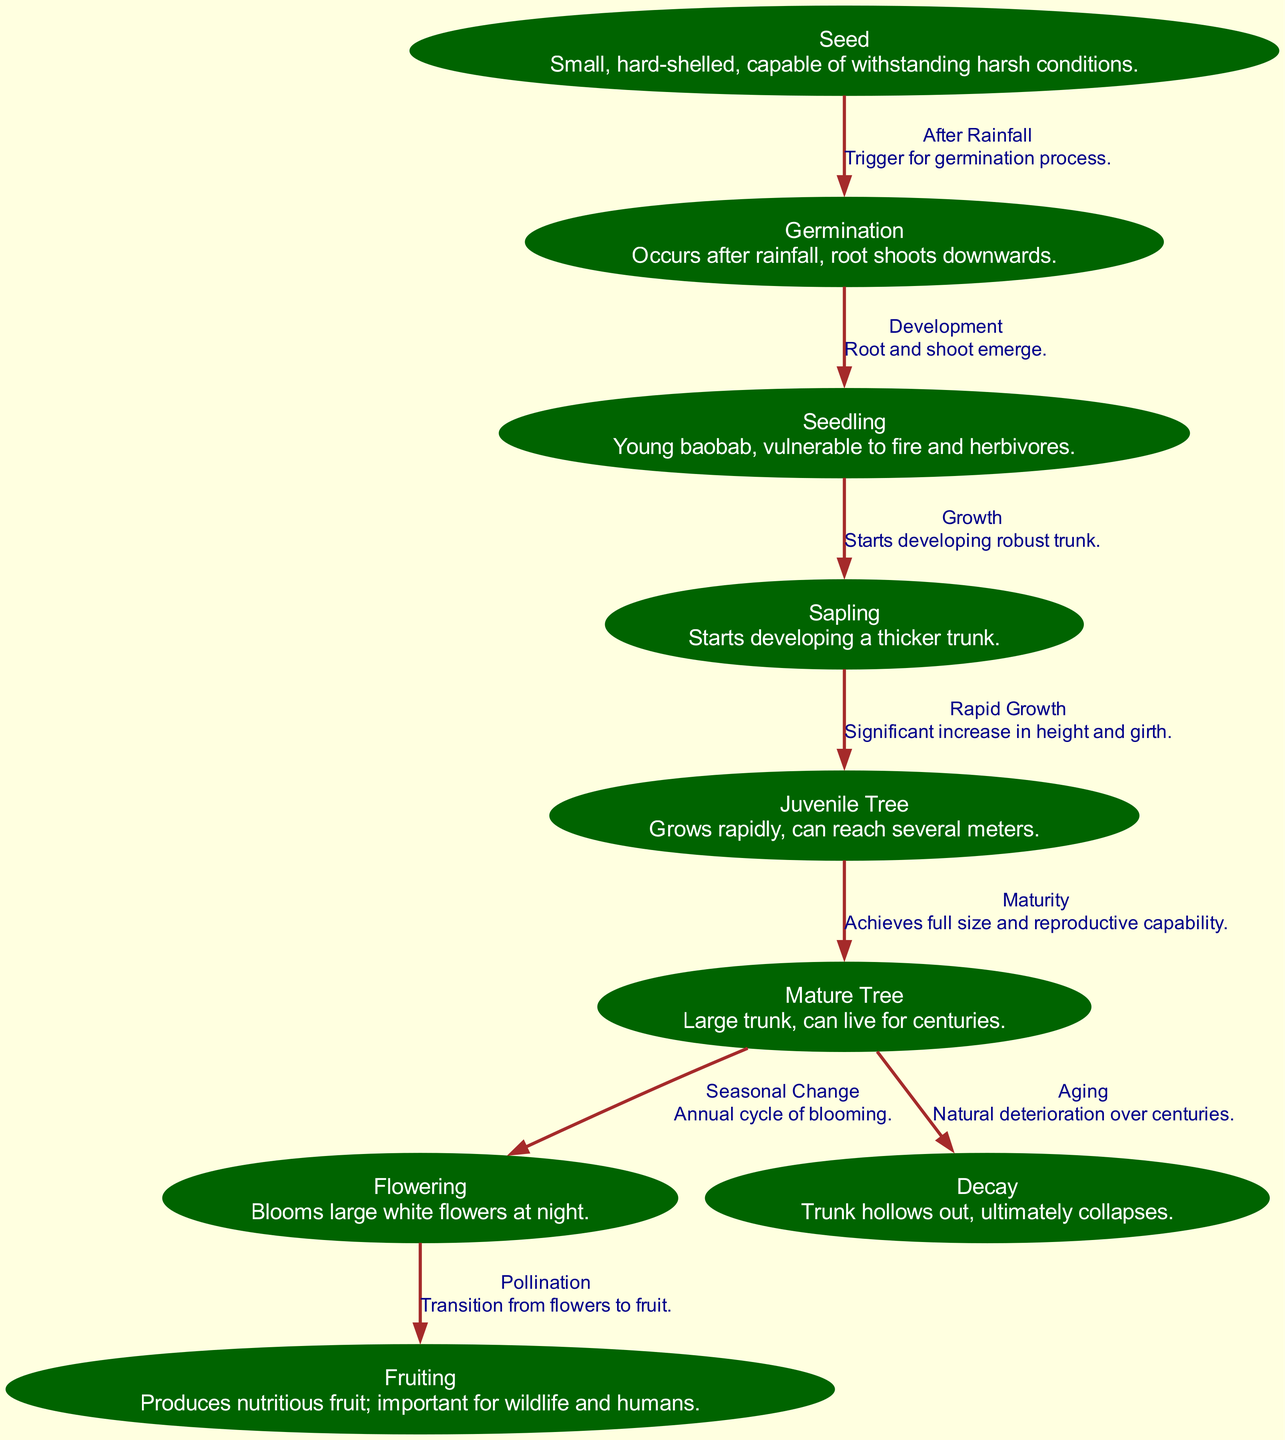What is the first stage of the baobab tree life cycle? The diagram shows that the first stage is the "Seed", which is identified as small and hard-shelled.
Answer: Seed How many main nodes are there in the life cycle of the African Baobab Tree? By counting the nodes listed in the diagram, we find there are nine main nodes representing different stages of the lifecycle.
Answer: 9 What type of tree is produced in the juvenile phase? The juvenile phase is simply labeled as "Juvenile Tree," indicating the tree's stage before it matures.
Answer: Juvenile Tree What happens after the flowering stage? The diagram indicates that after the flowering stage, the next stage is "Fruiting," which follows pollination.
Answer: Fruiting What connects the mature tree to both the flowering and decay stages? The connections show that the "Mature Tree" is linked to both "Flowering" (seasonal change) and "Decay" (natural deterioration), indicating its dual role at that stage.
Answer: Flowering and Decay What is a key trigger for germination in the baobab tree? The diagram specifies that rainfall is the trigger for the germination process to initiate.
Answer: Rainfall During which stage does the baobab tree develop a thicker trunk? The diagram describes that the "Sapling" stage is when the tree starts developing a thicker trunk as it grows.
Answer: Sapling What is the description of the fruiting stage? In the diagram, the fruiting stage is described as producing nutritious fruit, which is important for wildlife and humans.
Answer: Produces nutritious fruit What is indicated by the transition from flowering to fruiting? It indicates that pollination occurs, and the flowers transform into fruit during this stage of the lifecycle.
Answer: Pollination 